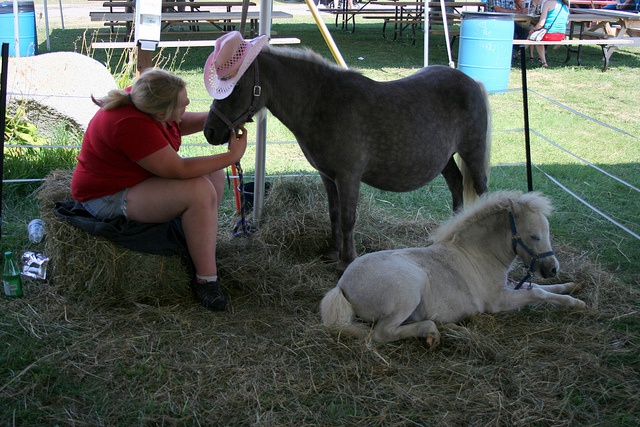Describe the objects in this image and their specific colors. I can see horse in beige, black, gray, and darkgray tones, horse in beige, gray, and black tones, people in beige, black, maroon, and gray tones, dining table in beige, black, ivory, gray, and darkgray tones, and bench in beige, darkgray, gray, black, and ivory tones in this image. 